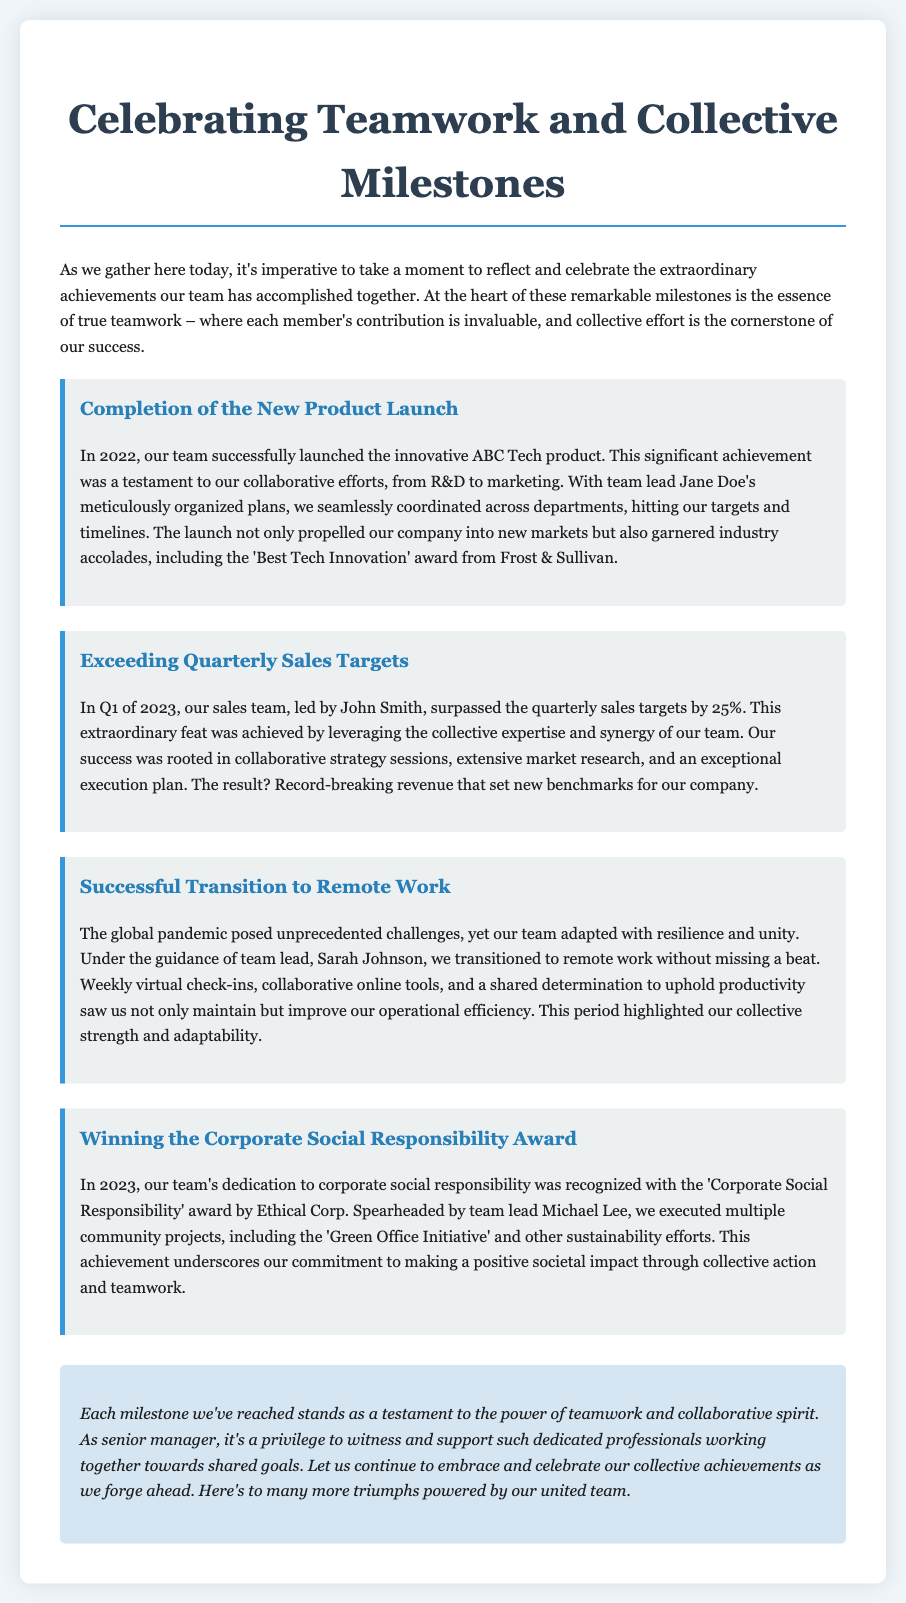What was launched in 2022? The document states that the innovative ABC Tech product was launched in 2022.
Answer: ABC Tech product Who was the team lead for the successful transition to remote work? According to the document, Sarah Johnson was the team lead for the successful transition to remote work.
Answer: Sarah Johnson By what percentage did the sales team exceed quarterly sales targets in Q1 of 2023? The document mentions that the sales team surpassed the quarterly sales targets by 25%.
Answer: 25% What award did the team win in 2023 related to corporate social responsibility? The document states that the team received the 'Corporate Social Responsibility' award from Ethical Corp in 2023.
Answer: Corporate Social Responsibility What was a key factor in the success of the new product launch? The document highlights that meticulous planning by team lead Jane Doe was a key factor in the success of the new product launch.
Answer: Meticulous planning Which project exemplified the team's adaptability during the pandemic? The document describes the successful transition to remote work as an example of the team's adaptability during the pandemic.
Answer: Successful transition to remote work What was emphasized as the cornerstone of success throughout the document? The document emphasizes that collective effort is the cornerstone of success throughout.
Answer: Collective effort How did the document conclude about the power of teamwork? The document concludes by stating that each milestone is a testament to the power of teamwork and collaborative spirit.
Answer: Power of teamwork What type of event is this document specifically written for? The document is specifically written for a eulogy reflecting on collaborative achievements and project triumphs.
Answer: Eulogy 